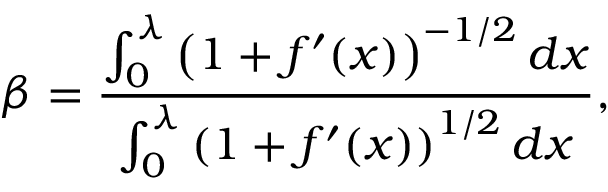Convert formula to latex. <formula><loc_0><loc_0><loc_500><loc_500>\beta = \frac { \int _ { 0 } ^ { \lambda } \left ( 1 + f ^ { \prime } ( x ) \right ) ^ { - 1 / 2 } d x } { \int _ { 0 } ^ { \lambda } \left ( 1 + f ^ { \prime } ( x ) \right ) ^ { 1 / 2 } d x } ,</formula> 